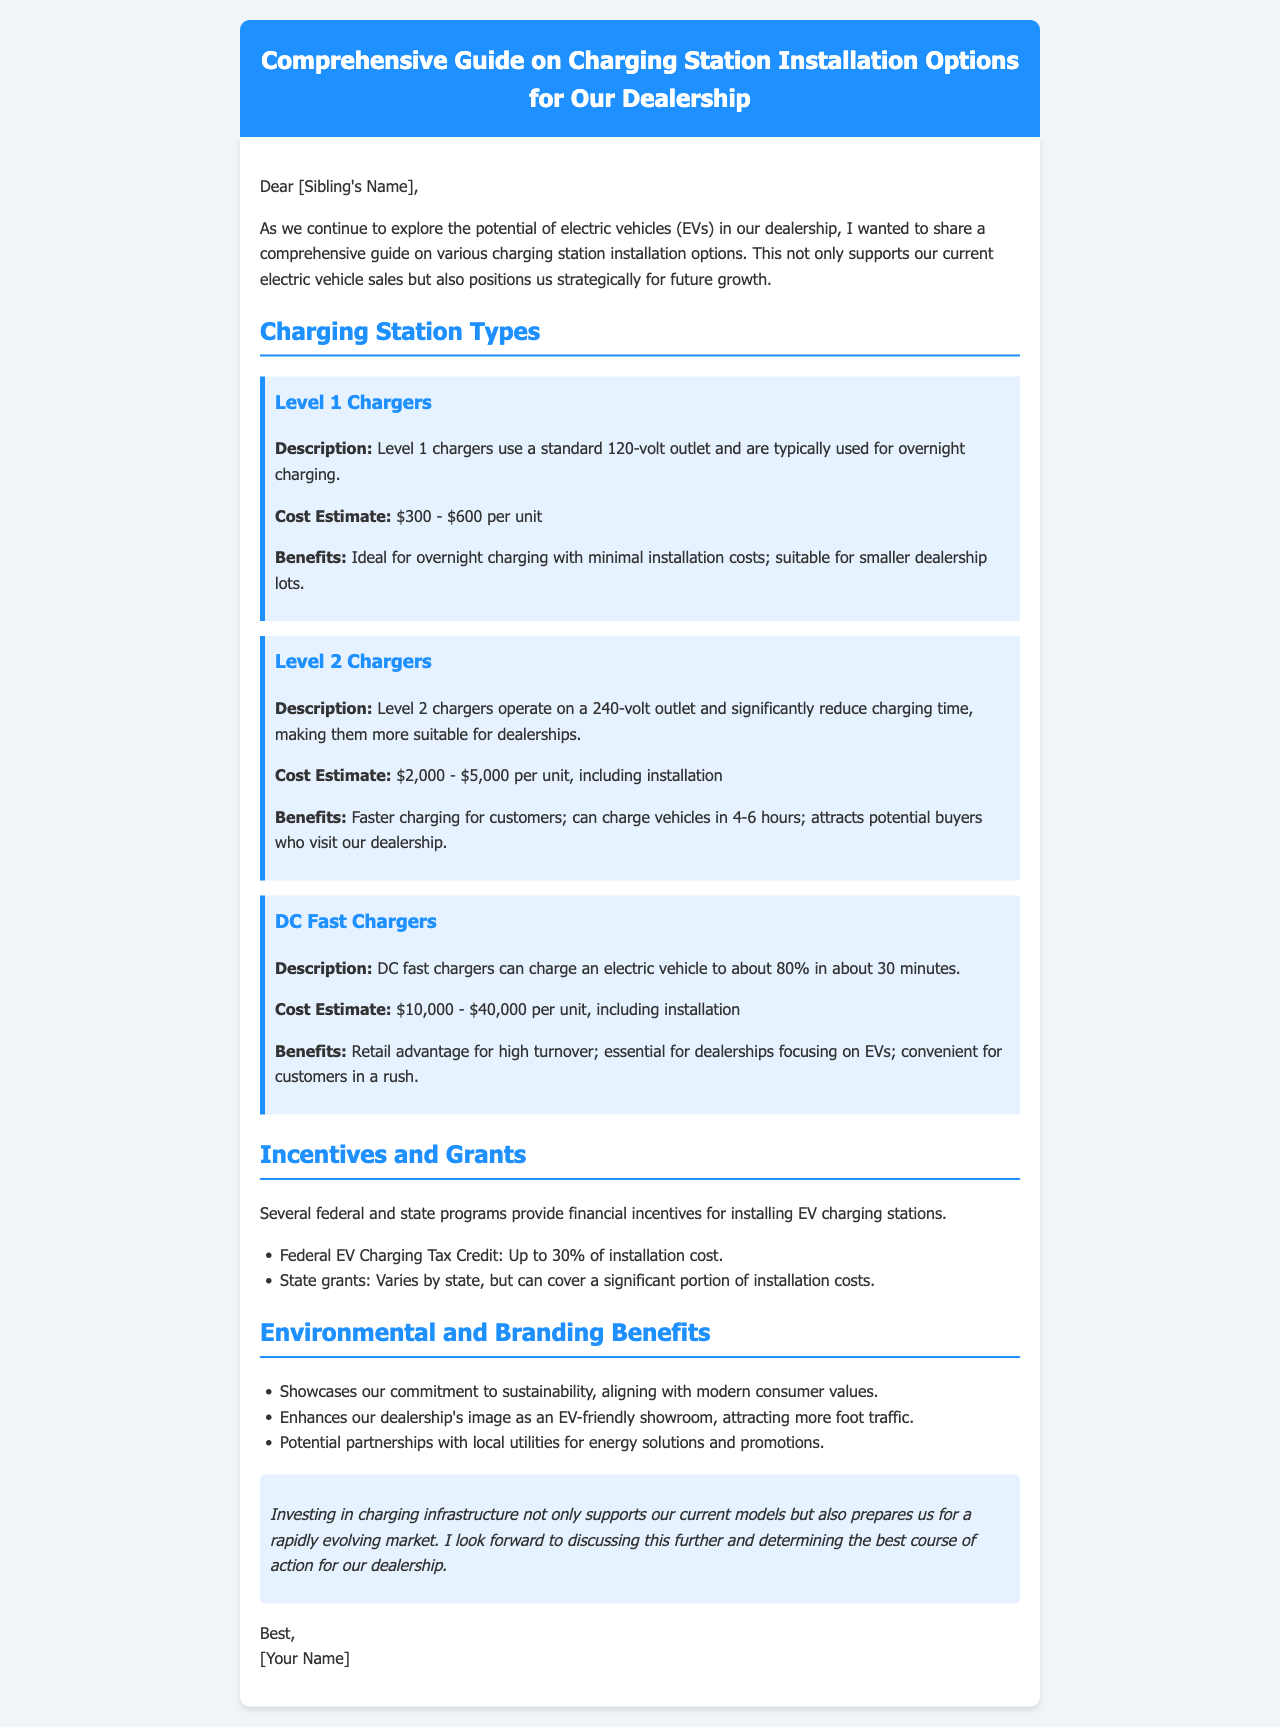what is the title of the document? The title is displayed prominently at the top of the document.
Answer: Comprehensive Guide on Charging Station Installation Options for Our Dealership how much does a Level 1 charger cost? The cost estimate for a Level 1 charger is mentioned in the specific section for it.
Answer: $300 - $600 per unit what is the charging time for Level 2 chargers? The document specifies the charging time for Level 2 chargers in their description.
Answer: 4-6 hours what percentage can the Federal EV Charging Tax Credit cover? The document states the percentage of the installation cost that can be covered by the tax credit.
Answer: Up to 30% what is the primary benefit of installing DC Fast Chargers? The document highlights the key advantage of having DC Fast Chargers in the benefits section.
Answer: Retail advantage for high turnover how does the installation of charging stations align with consumer values? This reasoning is inferred from the provided environmental benefits in the document.
Answer: Showcases our commitment to sustainability what is the minimum cost for Level 2 chargers including installation? The document lists the cost estimate range for Level 2 chargers, and the minimum is specified.
Answer: $2,000 what is mentioned about potential partnerships with local utilities? The document discusses potential partnerships in the benefits section under Environmental and Branding Benefits.
Answer: Energy solutions and promotions 